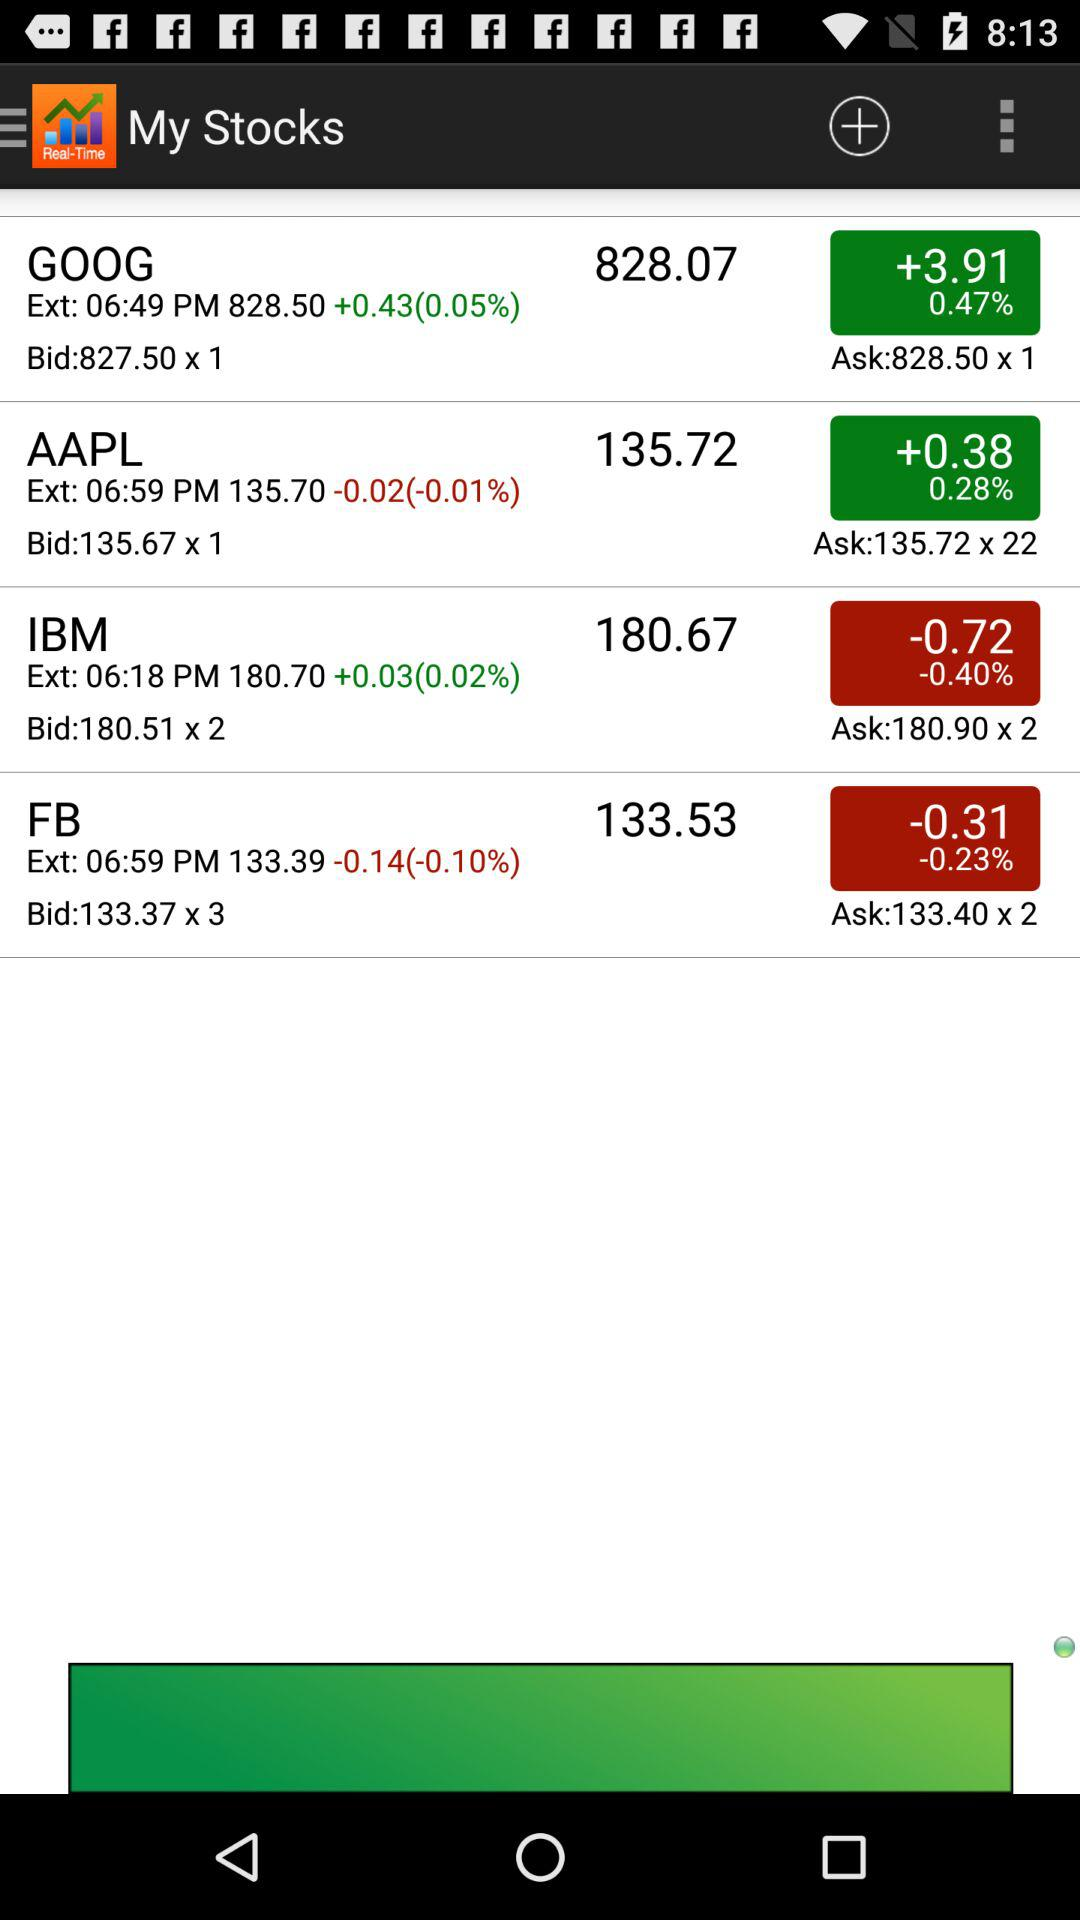What is the percentage decrease for IBM? The percentage decrease is 0.40. 